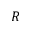<formula> <loc_0><loc_0><loc_500><loc_500>R</formula> 